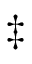<formula> <loc_0><loc_0><loc_500><loc_500>\ddagger</formula> 